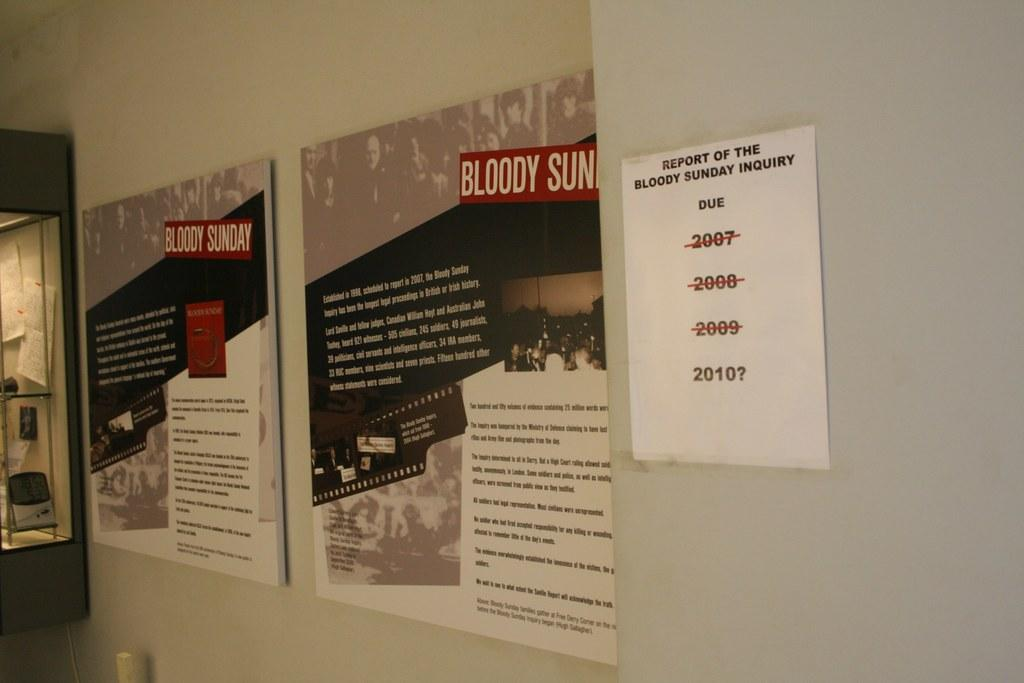Provide a one-sentence caption for the provided image. A white piece of paper titled Report of the Bloody Sunday Inquiry is taped to the wall. 